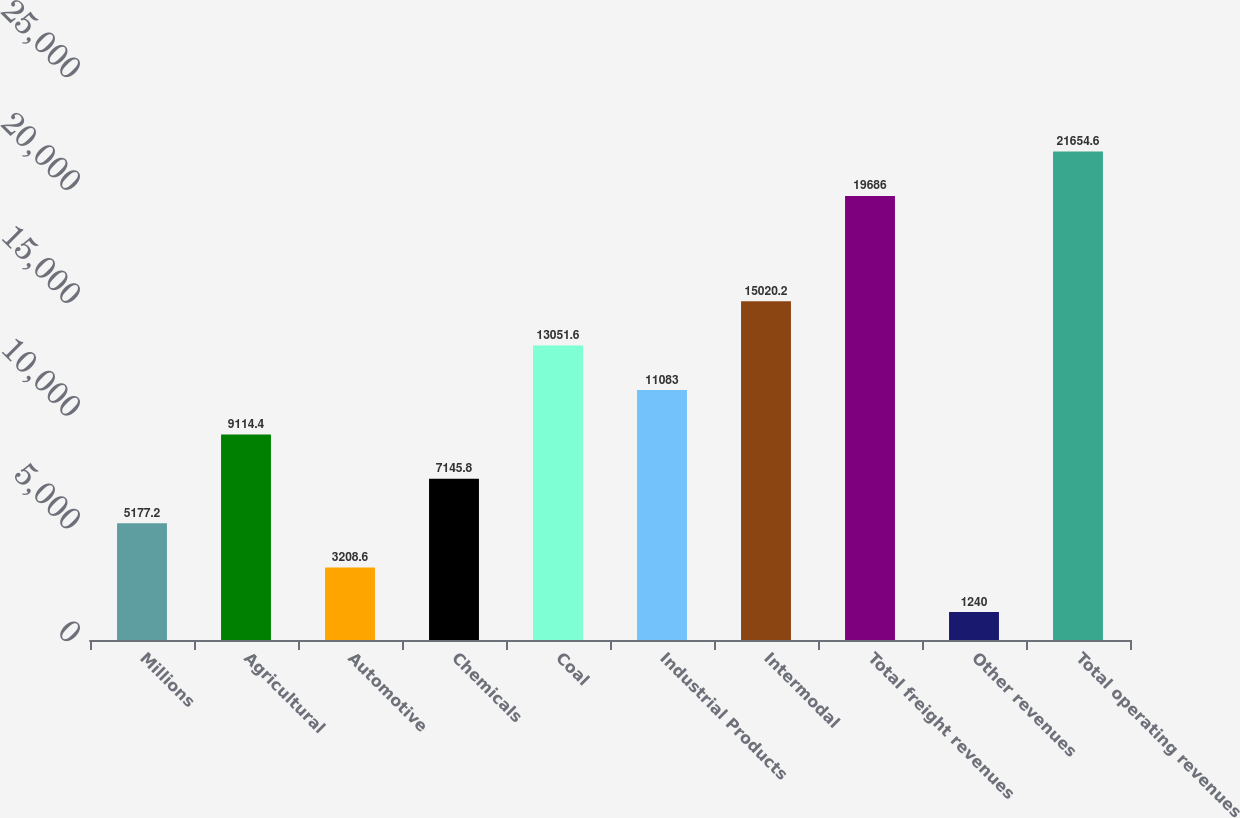<chart> <loc_0><loc_0><loc_500><loc_500><bar_chart><fcel>Millions<fcel>Agricultural<fcel>Automotive<fcel>Chemicals<fcel>Coal<fcel>Industrial Products<fcel>Intermodal<fcel>Total freight revenues<fcel>Other revenues<fcel>Total operating revenues<nl><fcel>5177.2<fcel>9114.4<fcel>3208.6<fcel>7145.8<fcel>13051.6<fcel>11083<fcel>15020.2<fcel>19686<fcel>1240<fcel>21654.6<nl></chart> 